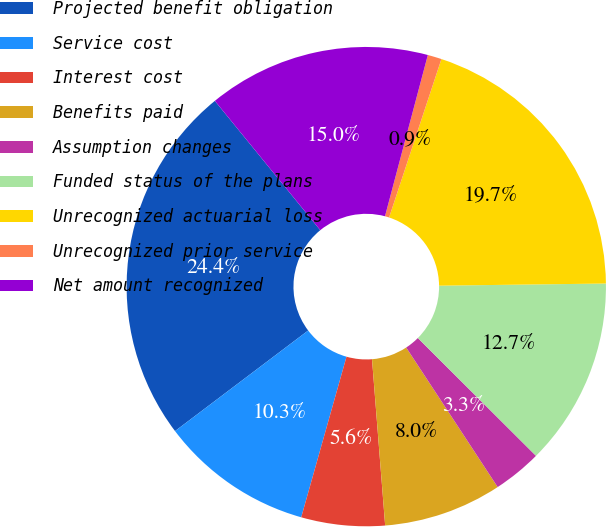Convert chart. <chart><loc_0><loc_0><loc_500><loc_500><pie_chart><fcel>Projected benefit obligation<fcel>Service cost<fcel>Interest cost<fcel>Benefits paid<fcel>Assumption changes<fcel>Funded status of the plans<fcel>Unrecognized actuarial loss<fcel>Unrecognized prior service<fcel>Net amount recognized<nl><fcel>24.41%<fcel>10.33%<fcel>5.63%<fcel>7.98%<fcel>3.29%<fcel>12.68%<fcel>19.72%<fcel>0.94%<fcel>15.02%<nl></chart> 